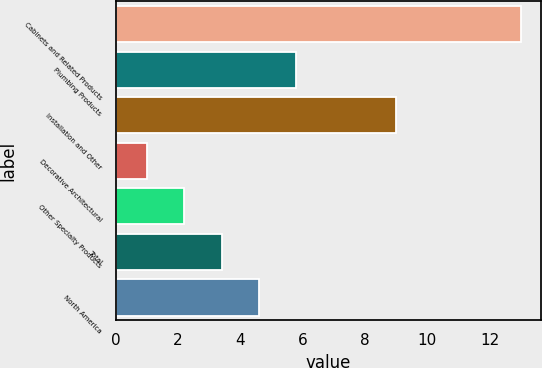Convert chart to OTSL. <chart><loc_0><loc_0><loc_500><loc_500><bar_chart><fcel>Cabinets and Related Products<fcel>Plumbing Products<fcel>Installation and Other<fcel>Decorative Architectural<fcel>Other Specialty Products<fcel>Total<fcel>North America<nl><fcel>13<fcel>5.8<fcel>9<fcel>1<fcel>2.2<fcel>3.4<fcel>4.6<nl></chart> 